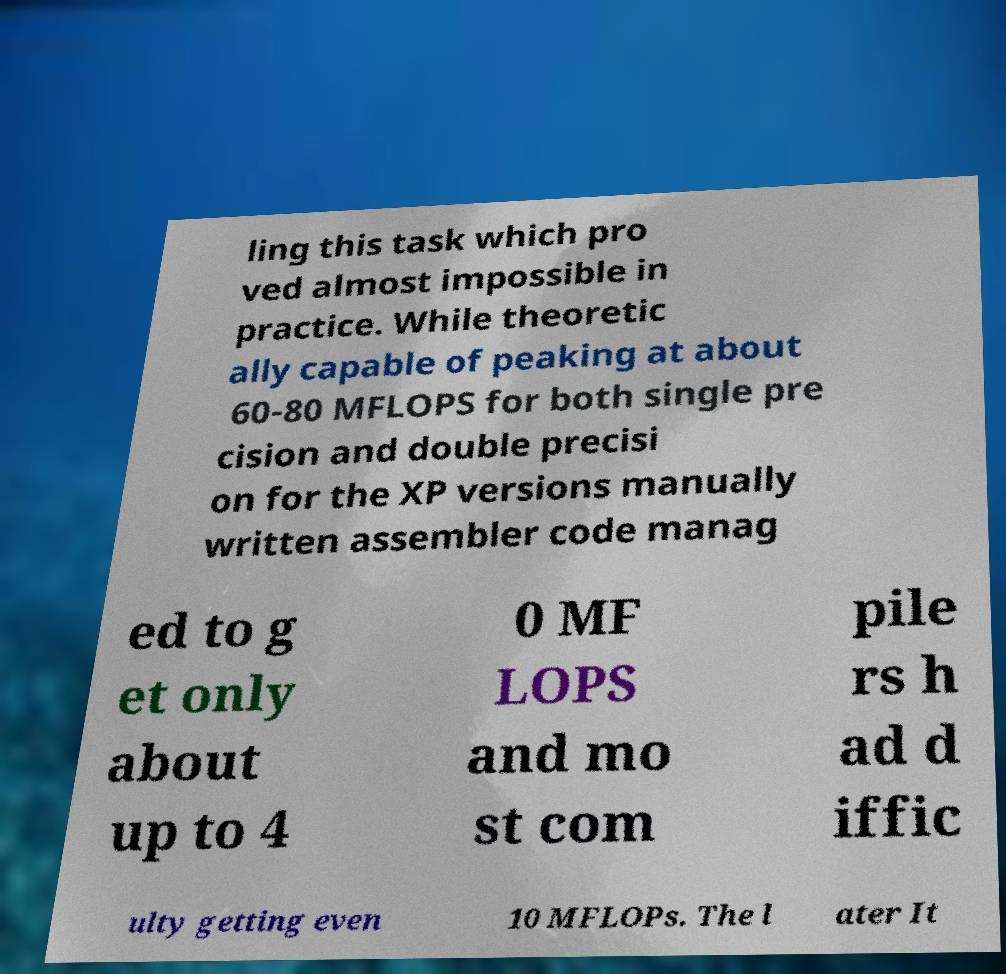Can you read and provide the text displayed in the image?This photo seems to have some interesting text. Can you extract and type it out for me? ling this task which pro ved almost impossible in practice. While theoretic ally capable of peaking at about 60-80 MFLOPS for both single pre cision and double precisi on for the XP versions manually written assembler code manag ed to g et only about up to 4 0 MF LOPS and mo st com pile rs h ad d iffic ulty getting even 10 MFLOPs. The l ater It 